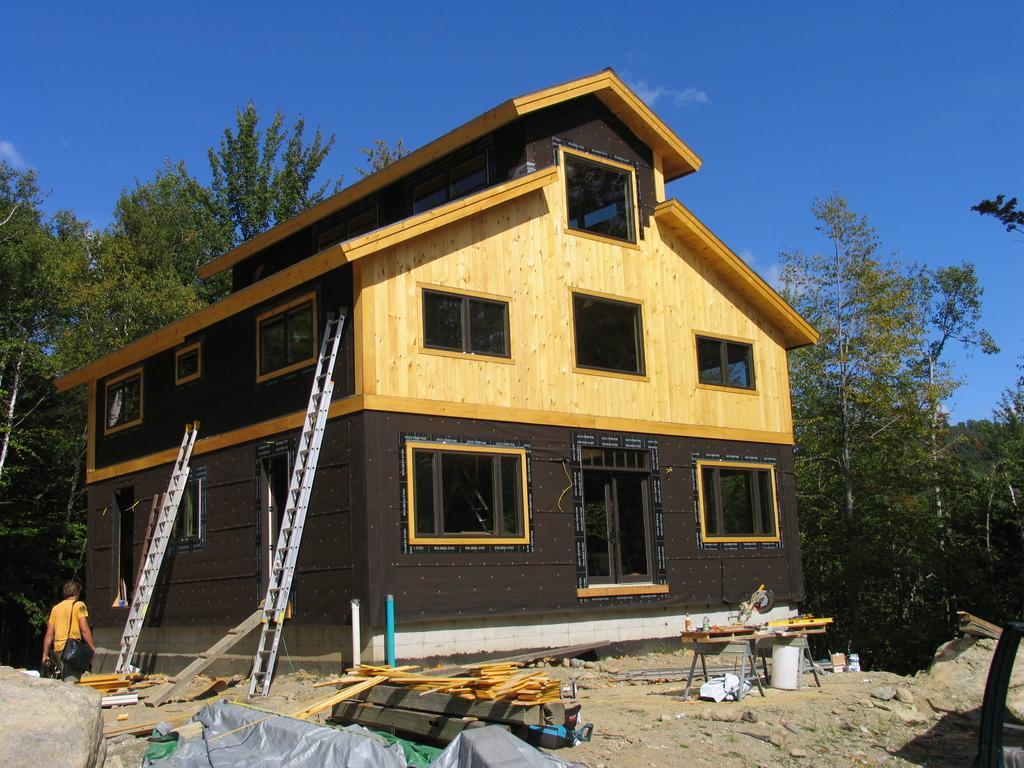How would you summarize this image in a sentence or two? This image is taken outdoors. At the top of the image there is a sky with clouds. At the bottom of the image there is a ground and there are many things on the ground. In the middle of the image there is a house with wooden walls, windows, a door and a roof. There are two ladders and a man is walking on the ground. In the background there are many trees. 